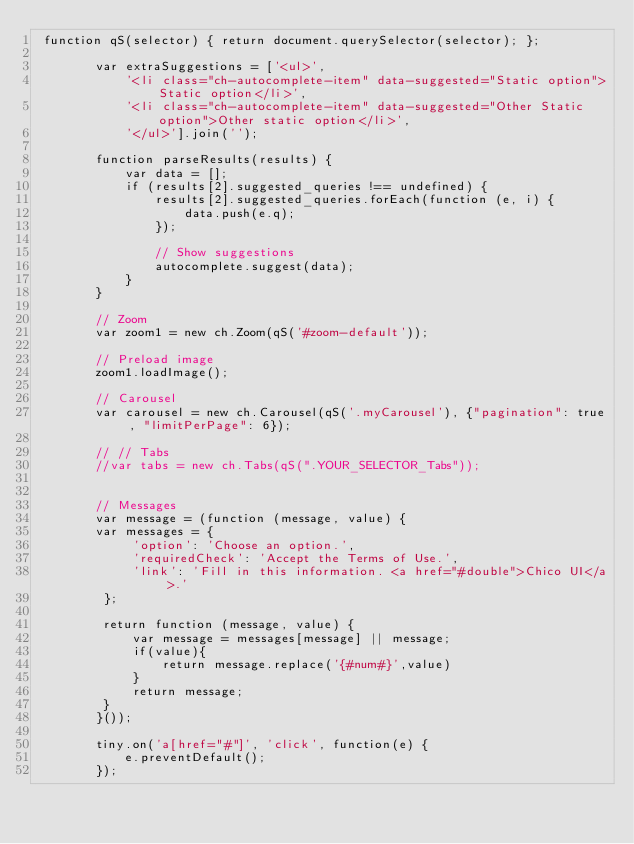Convert code to text. <code><loc_0><loc_0><loc_500><loc_500><_JavaScript_> function qS(selector) { return document.querySelector(selector); };

        var extraSuggestions = ['<ul>',
            '<li class="ch-autocomplete-item" data-suggested="Static option">Static option</li>',
            '<li class="ch-autocomplete-item" data-suggested="Other Static option">Other static option</li>',
            '</ul>'].join('');

        function parseResults(results) {
            var data = [];
            if (results[2].suggested_queries !== undefined) {
                results[2].suggested_queries.forEach(function (e, i) {
                    data.push(e.q);
                });

                // Show suggestions
                autocomplete.suggest(data);
            }
        }

        // Zoom
        var zoom1 = new ch.Zoom(qS('#zoom-default'));

        // Preload image
        zoom1.loadImage();

        // Carousel
        var carousel = new ch.Carousel(qS('.myCarousel'), {"pagination": true, "limitPerPage": 6});

        // // Tabs
        //var tabs = new ch.Tabs(qS(".YOUR_SELECTOR_Tabs"));


        // Messages
        var message = (function (message, value) {
        var messages = {
             'option': 'Choose an option.',
             'requiredCheck': 'Accept the Terms of Use.',
             'link': 'Fill in this information. <a href="#double">Chico UI</a>.'
         };

         return function (message, value) {
             var message = messages[message] || message;
             if(value){
                 return message.replace('{#num#}',value)
             }
             return message;
         }
        }());

        tiny.on('a[href="#"]', 'click', function(e) {
            e.preventDefault();
        });
</code> 